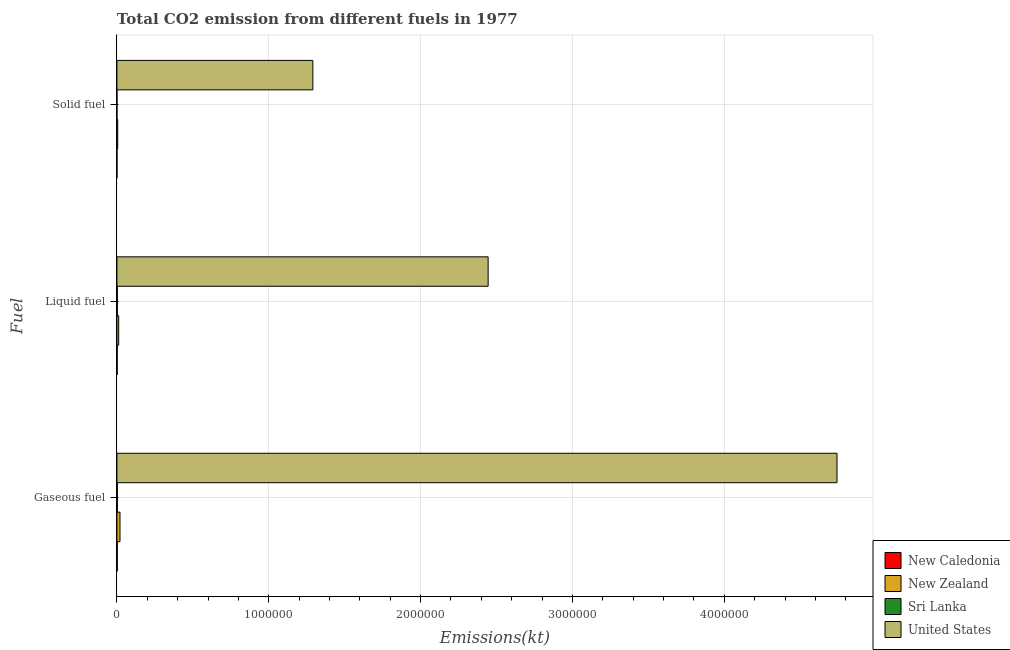How many different coloured bars are there?
Your response must be concise. 4. How many groups of bars are there?
Your answer should be very brief. 3. How many bars are there on the 3rd tick from the top?
Keep it short and to the point. 4. What is the label of the 3rd group of bars from the top?
Make the answer very short. Gaseous fuel. What is the amount of co2 emissions from gaseous fuel in United States?
Your answer should be compact. 4.74e+06. Across all countries, what is the maximum amount of co2 emissions from solid fuel?
Provide a short and direct response. 1.29e+06. Across all countries, what is the minimum amount of co2 emissions from liquid fuel?
Provide a succinct answer. 1866.5. In which country was the amount of co2 emissions from liquid fuel minimum?
Offer a terse response. New Caledonia. What is the total amount of co2 emissions from solid fuel in the graph?
Offer a terse response. 1.30e+06. What is the difference between the amount of co2 emissions from liquid fuel in New Zealand and that in Sri Lanka?
Provide a succinct answer. 8980.48. What is the difference between the amount of co2 emissions from solid fuel in United States and the amount of co2 emissions from gaseous fuel in New Caledonia?
Give a very brief answer. 1.29e+06. What is the average amount of co2 emissions from solid fuel per country?
Keep it short and to the point. 3.24e+05. What is the difference between the amount of co2 emissions from liquid fuel and amount of co2 emissions from solid fuel in New Zealand?
Offer a very short reply. 6505.26. In how many countries, is the amount of co2 emissions from gaseous fuel greater than 4400000 kt?
Make the answer very short. 1. What is the ratio of the amount of co2 emissions from gaseous fuel in Sri Lanka to that in United States?
Give a very brief answer. 0. What is the difference between the highest and the second highest amount of co2 emissions from liquid fuel?
Make the answer very short. 2.43e+06. What is the difference between the highest and the lowest amount of co2 emissions from liquid fuel?
Offer a terse response. 2.44e+06. In how many countries, is the amount of co2 emissions from solid fuel greater than the average amount of co2 emissions from solid fuel taken over all countries?
Make the answer very short. 1. Is the sum of the amount of co2 emissions from liquid fuel in United States and New Caledonia greater than the maximum amount of co2 emissions from gaseous fuel across all countries?
Your response must be concise. No. What does the 1st bar from the top in Liquid fuel represents?
Offer a terse response. United States. Is it the case that in every country, the sum of the amount of co2 emissions from gaseous fuel and amount of co2 emissions from liquid fuel is greater than the amount of co2 emissions from solid fuel?
Offer a very short reply. Yes. How many bars are there?
Make the answer very short. 12. Are all the bars in the graph horizontal?
Give a very brief answer. Yes. How many countries are there in the graph?
Provide a succinct answer. 4. What is the difference between two consecutive major ticks on the X-axis?
Ensure brevity in your answer.  1.00e+06. Does the graph contain any zero values?
Your answer should be very brief. No. Does the graph contain grids?
Give a very brief answer. Yes. How many legend labels are there?
Offer a terse response. 4. What is the title of the graph?
Offer a very short reply. Total CO2 emission from different fuels in 1977. What is the label or title of the X-axis?
Offer a very short reply. Emissions(kt). What is the label or title of the Y-axis?
Keep it short and to the point. Fuel. What is the Emissions(kt) in New Caledonia in Gaseous fuel?
Give a very brief answer. 2141.53. What is the Emissions(kt) of New Zealand in Gaseous fuel?
Provide a short and direct response. 2.03e+04. What is the Emissions(kt) in Sri Lanka in Gaseous fuel?
Ensure brevity in your answer.  2918.93. What is the Emissions(kt) of United States in Gaseous fuel?
Give a very brief answer. 4.74e+06. What is the Emissions(kt) of New Caledonia in Liquid fuel?
Give a very brief answer. 1866.5. What is the Emissions(kt) of New Zealand in Liquid fuel?
Provide a succinct answer. 1.17e+04. What is the Emissions(kt) in Sri Lanka in Liquid fuel?
Keep it short and to the point. 2742.92. What is the Emissions(kt) in United States in Liquid fuel?
Your answer should be very brief. 2.44e+06. What is the Emissions(kt) in New Caledonia in Solid fuel?
Offer a very short reply. 249.36. What is the Emissions(kt) in New Zealand in Solid fuel?
Your answer should be compact. 5218.14. What is the Emissions(kt) in Sri Lanka in Solid fuel?
Keep it short and to the point. 3.67. What is the Emissions(kt) of United States in Solid fuel?
Your answer should be compact. 1.29e+06. Across all Fuel, what is the maximum Emissions(kt) in New Caledonia?
Keep it short and to the point. 2141.53. Across all Fuel, what is the maximum Emissions(kt) in New Zealand?
Ensure brevity in your answer.  2.03e+04. Across all Fuel, what is the maximum Emissions(kt) of Sri Lanka?
Give a very brief answer. 2918.93. Across all Fuel, what is the maximum Emissions(kt) of United States?
Offer a very short reply. 4.74e+06. Across all Fuel, what is the minimum Emissions(kt) in New Caledonia?
Your response must be concise. 249.36. Across all Fuel, what is the minimum Emissions(kt) of New Zealand?
Give a very brief answer. 5218.14. Across all Fuel, what is the minimum Emissions(kt) of Sri Lanka?
Your answer should be compact. 3.67. Across all Fuel, what is the minimum Emissions(kt) in United States?
Your answer should be compact. 1.29e+06. What is the total Emissions(kt) of New Caledonia in the graph?
Ensure brevity in your answer.  4257.39. What is the total Emissions(kt) of New Zealand in the graph?
Give a very brief answer. 3.72e+04. What is the total Emissions(kt) in Sri Lanka in the graph?
Keep it short and to the point. 5665.52. What is the total Emissions(kt) of United States in the graph?
Your response must be concise. 8.48e+06. What is the difference between the Emissions(kt) in New Caledonia in Gaseous fuel and that in Liquid fuel?
Provide a short and direct response. 275.02. What is the difference between the Emissions(kt) in New Zealand in Gaseous fuel and that in Liquid fuel?
Offer a very short reply. 8577.11. What is the difference between the Emissions(kt) of Sri Lanka in Gaseous fuel and that in Liquid fuel?
Give a very brief answer. 176.02. What is the difference between the Emissions(kt) in United States in Gaseous fuel and that in Liquid fuel?
Ensure brevity in your answer.  2.30e+06. What is the difference between the Emissions(kt) of New Caledonia in Gaseous fuel and that in Solid fuel?
Your response must be concise. 1892.17. What is the difference between the Emissions(kt) in New Zealand in Gaseous fuel and that in Solid fuel?
Offer a very short reply. 1.51e+04. What is the difference between the Emissions(kt) in Sri Lanka in Gaseous fuel and that in Solid fuel?
Make the answer very short. 2915.26. What is the difference between the Emissions(kt) of United States in Gaseous fuel and that in Solid fuel?
Ensure brevity in your answer.  3.45e+06. What is the difference between the Emissions(kt) of New Caledonia in Liquid fuel and that in Solid fuel?
Give a very brief answer. 1617.15. What is the difference between the Emissions(kt) in New Zealand in Liquid fuel and that in Solid fuel?
Offer a very short reply. 6505.26. What is the difference between the Emissions(kt) of Sri Lanka in Liquid fuel and that in Solid fuel?
Ensure brevity in your answer.  2739.25. What is the difference between the Emissions(kt) in United States in Liquid fuel and that in Solid fuel?
Keep it short and to the point. 1.15e+06. What is the difference between the Emissions(kt) of New Caledonia in Gaseous fuel and the Emissions(kt) of New Zealand in Liquid fuel?
Keep it short and to the point. -9581.87. What is the difference between the Emissions(kt) in New Caledonia in Gaseous fuel and the Emissions(kt) in Sri Lanka in Liquid fuel?
Your response must be concise. -601.39. What is the difference between the Emissions(kt) in New Caledonia in Gaseous fuel and the Emissions(kt) in United States in Liquid fuel?
Keep it short and to the point. -2.44e+06. What is the difference between the Emissions(kt) in New Zealand in Gaseous fuel and the Emissions(kt) in Sri Lanka in Liquid fuel?
Give a very brief answer. 1.76e+04. What is the difference between the Emissions(kt) in New Zealand in Gaseous fuel and the Emissions(kt) in United States in Liquid fuel?
Offer a very short reply. -2.42e+06. What is the difference between the Emissions(kt) of Sri Lanka in Gaseous fuel and the Emissions(kt) of United States in Liquid fuel?
Make the answer very short. -2.44e+06. What is the difference between the Emissions(kt) in New Caledonia in Gaseous fuel and the Emissions(kt) in New Zealand in Solid fuel?
Make the answer very short. -3076.61. What is the difference between the Emissions(kt) of New Caledonia in Gaseous fuel and the Emissions(kt) of Sri Lanka in Solid fuel?
Offer a terse response. 2137.86. What is the difference between the Emissions(kt) in New Caledonia in Gaseous fuel and the Emissions(kt) in United States in Solid fuel?
Provide a succinct answer. -1.29e+06. What is the difference between the Emissions(kt) of New Zealand in Gaseous fuel and the Emissions(kt) of Sri Lanka in Solid fuel?
Keep it short and to the point. 2.03e+04. What is the difference between the Emissions(kt) in New Zealand in Gaseous fuel and the Emissions(kt) in United States in Solid fuel?
Offer a very short reply. -1.27e+06. What is the difference between the Emissions(kt) of Sri Lanka in Gaseous fuel and the Emissions(kt) of United States in Solid fuel?
Ensure brevity in your answer.  -1.29e+06. What is the difference between the Emissions(kt) of New Caledonia in Liquid fuel and the Emissions(kt) of New Zealand in Solid fuel?
Ensure brevity in your answer.  -3351.64. What is the difference between the Emissions(kt) in New Caledonia in Liquid fuel and the Emissions(kt) in Sri Lanka in Solid fuel?
Provide a short and direct response. 1862.84. What is the difference between the Emissions(kt) in New Caledonia in Liquid fuel and the Emissions(kt) in United States in Solid fuel?
Provide a short and direct response. -1.29e+06. What is the difference between the Emissions(kt) of New Zealand in Liquid fuel and the Emissions(kt) of Sri Lanka in Solid fuel?
Keep it short and to the point. 1.17e+04. What is the difference between the Emissions(kt) in New Zealand in Liquid fuel and the Emissions(kt) in United States in Solid fuel?
Make the answer very short. -1.28e+06. What is the difference between the Emissions(kt) in Sri Lanka in Liquid fuel and the Emissions(kt) in United States in Solid fuel?
Offer a terse response. -1.29e+06. What is the average Emissions(kt) in New Caledonia per Fuel?
Offer a terse response. 1419.13. What is the average Emissions(kt) in New Zealand per Fuel?
Ensure brevity in your answer.  1.24e+04. What is the average Emissions(kt) in Sri Lanka per Fuel?
Give a very brief answer. 1888.51. What is the average Emissions(kt) in United States per Fuel?
Make the answer very short. 2.83e+06. What is the difference between the Emissions(kt) in New Caledonia and Emissions(kt) in New Zealand in Gaseous fuel?
Provide a succinct answer. -1.82e+04. What is the difference between the Emissions(kt) in New Caledonia and Emissions(kt) in Sri Lanka in Gaseous fuel?
Keep it short and to the point. -777.4. What is the difference between the Emissions(kt) in New Caledonia and Emissions(kt) in United States in Gaseous fuel?
Offer a terse response. -4.74e+06. What is the difference between the Emissions(kt) in New Zealand and Emissions(kt) in Sri Lanka in Gaseous fuel?
Ensure brevity in your answer.  1.74e+04. What is the difference between the Emissions(kt) in New Zealand and Emissions(kt) in United States in Gaseous fuel?
Ensure brevity in your answer.  -4.72e+06. What is the difference between the Emissions(kt) in Sri Lanka and Emissions(kt) in United States in Gaseous fuel?
Make the answer very short. -4.74e+06. What is the difference between the Emissions(kt) in New Caledonia and Emissions(kt) in New Zealand in Liquid fuel?
Offer a terse response. -9856.9. What is the difference between the Emissions(kt) of New Caledonia and Emissions(kt) of Sri Lanka in Liquid fuel?
Your response must be concise. -876.41. What is the difference between the Emissions(kt) of New Caledonia and Emissions(kt) of United States in Liquid fuel?
Keep it short and to the point. -2.44e+06. What is the difference between the Emissions(kt) of New Zealand and Emissions(kt) of Sri Lanka in Liquid fuel?
Your response must be concise. 8980.48. What is the difference between the Emissions(kt) in New Zealand and Emissions(kt) in United States in Liquid fuel?
Make the answer very short. -2.43e+06. What is the difference between the Emissions(kt) in Sri Lanka and Emissions(kt) in United States in Liquid fuel?
Give a very brief answer. -2.44e+06. What is the difference between the Emissions(kt) in New Caledonia and Emissions(kt) in New Zealand in Solid fuel?
Provide a short and direct response. -4968.78. What is the difference between the Emissions(kt) of New Caledonia and Emissions(kt) of Sri Lanka in Solid fuel?
Your answer should be very brief. 245.69. What is the difference between the Emissions(kt) in New Caledonia and Emissions(kt) in United States in Solid fuel?
Offer a terse response. -1.29e+06. What is the difference between the Emissions(kt) in New Zealand and Emissions(kt) in Sri Lanka in Solid fuel?
Your answer should be very brief. 5214.47. What is the difference between the Emissions(kt) in New Zealand and Emissions(kt) in United States in Solid fuel?
Ensure brevity in your answer.  -1.29e+06. What is the difference between the Emissions(kt) of Sri Lanka and Emissions(kt) of United States in Solid fuel?
Ensure brevity in your answer.  -1.29e+06. What is the ratio of the Emissions(kt) in New Caledonia in Gaseous fuel to that in Liquid fuel?
Your response must be concise. 1.15. What is the ratio of the Emissions(kt) of New Zealand in Gaseous fuel to that in Liquid fuel?
Make the answer very short. 1.73. What is the ratio of the Emissions(kt) in Sri Lanka in Gaseous fuel to that in Liquid fuel?
Keep it short and to the point. 1.06. What is the ratio of the Emissions(kt) in United States in Gaseous fuel to that in Liquid fuel?
Provide a succinct answer. 1.94. What is the ratio of the Emissions(kt) of New Caledonia in Gaseous fuel to that in Solid fuel?
Ensure brevity in your answer.  8.59. What is the ratio of the Emissions(kt) of New Zealand in Gaseous fuel to that in Solid fuel?
Your answer should be very brief. 3.89. What is the ratio of the Emissions(kt) of Sri Lanka in Gaseous fuel to that in Solid fuel?
Keep it short and to the point. 796. What is the ratio of the Emissions(kt) of United States in Gaseous fuel to that in Solid fuel?
Your answer should be very brief. 3.67. What is the ratio of the Emissions(kt) of New Caledonia in Liquid fuel to that in Solid fuel?
Provide a succinct answer. 7.49. What is the ratio of the Emissions(kt) in New Zealand in Liquid fuel to that in Solid fuel?
Ensure brevity in your answer.  2.25. What is the ratio of the Emissions(kt) in Sri Lanka in Liquid fuel to that in Solid fuel?
Provide a succinct answer. 748. What is the ratio of the Emissions(kt) in United States in Liquid fuel to that in Solid fuel?
Your response must be concise. 1.89. What is the difference between the highest and the second highest Emissions(kt) of New Caledonia?
Provide a succinct answer. 275.02. What is the difference between the highest and the second highest Emissions(kt) of New Zealand?
Your response must be concise. 8577.11. What is the difference between the highest and the second highest Emissions(kt) in Sri Lanka?
Your answer should be very brief. 176.02. What is the difference between the highest and the second highest Emissions(kt) in United States?
Provide a succinct answer. 2.30e+06. What is the difference between the highest and the lowest Emissions(kt) of New Caledonia?
Make the answer very short. 1892.17. What is the difference between the highest and the lowest Emissions(kt) in New Zealand?
Ensure brevity in your answer.  1.51e+04. What is the difference between the highest and the lowest Emissions(kt) of Sri Lanka?
Make the answer very short. 2915.26. What is the difference between the highest and the lowest Emissions(kt) of United States?
Your answer should be very brief. 3.45e+06. 